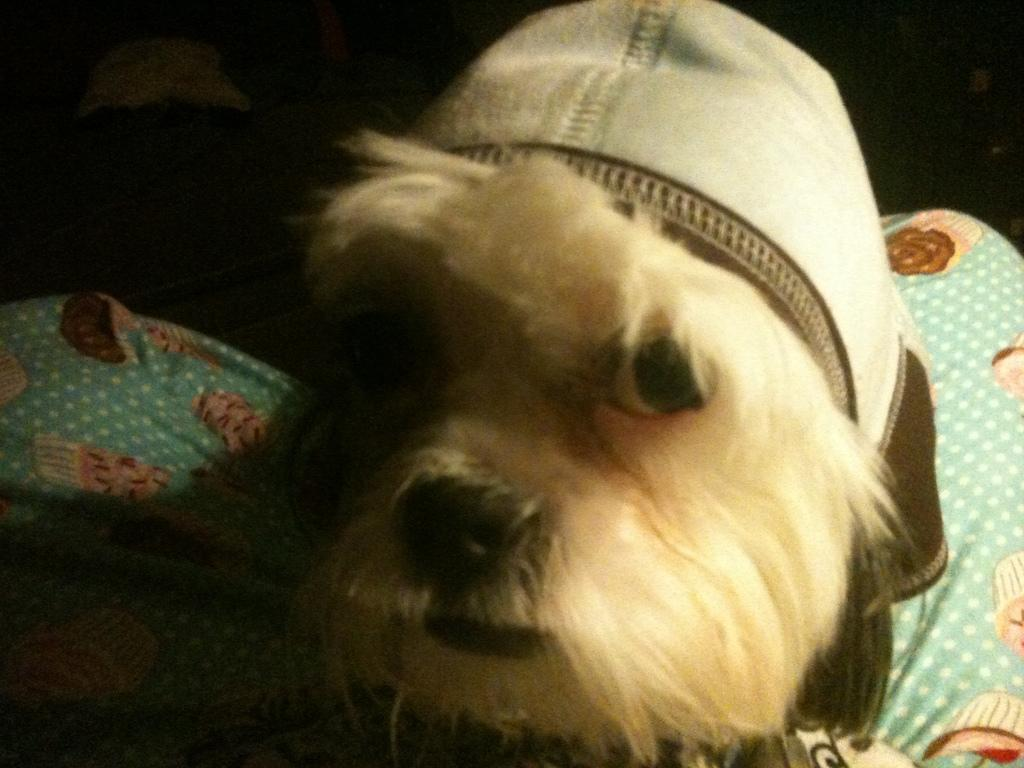What animal is present in the image? There is a dog in the image. What is the dog wearing? The dog is wearing a cap. What type of material is visible at the bottom of the image? There is cloth visible at the bottom of the image. Where is the mailbox located in the image? There is no mailbox present in the image. What is the top of the image made of? The top of the image is not made of any material, as it is a two-dimensional representation. Is there an oven visible in the image? There is no oven present in the image. 